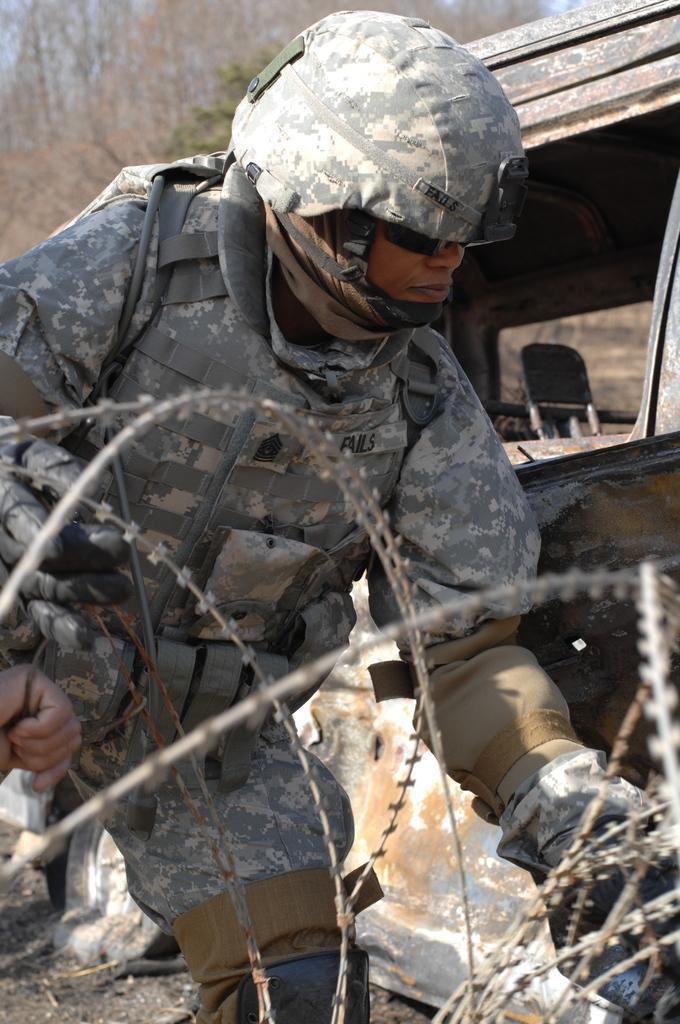Please provide a concise description of this image. In this image we can see one person wearing a helmet, we can see barbed fence, vehicle, in the background we can see the trees and the sky. 